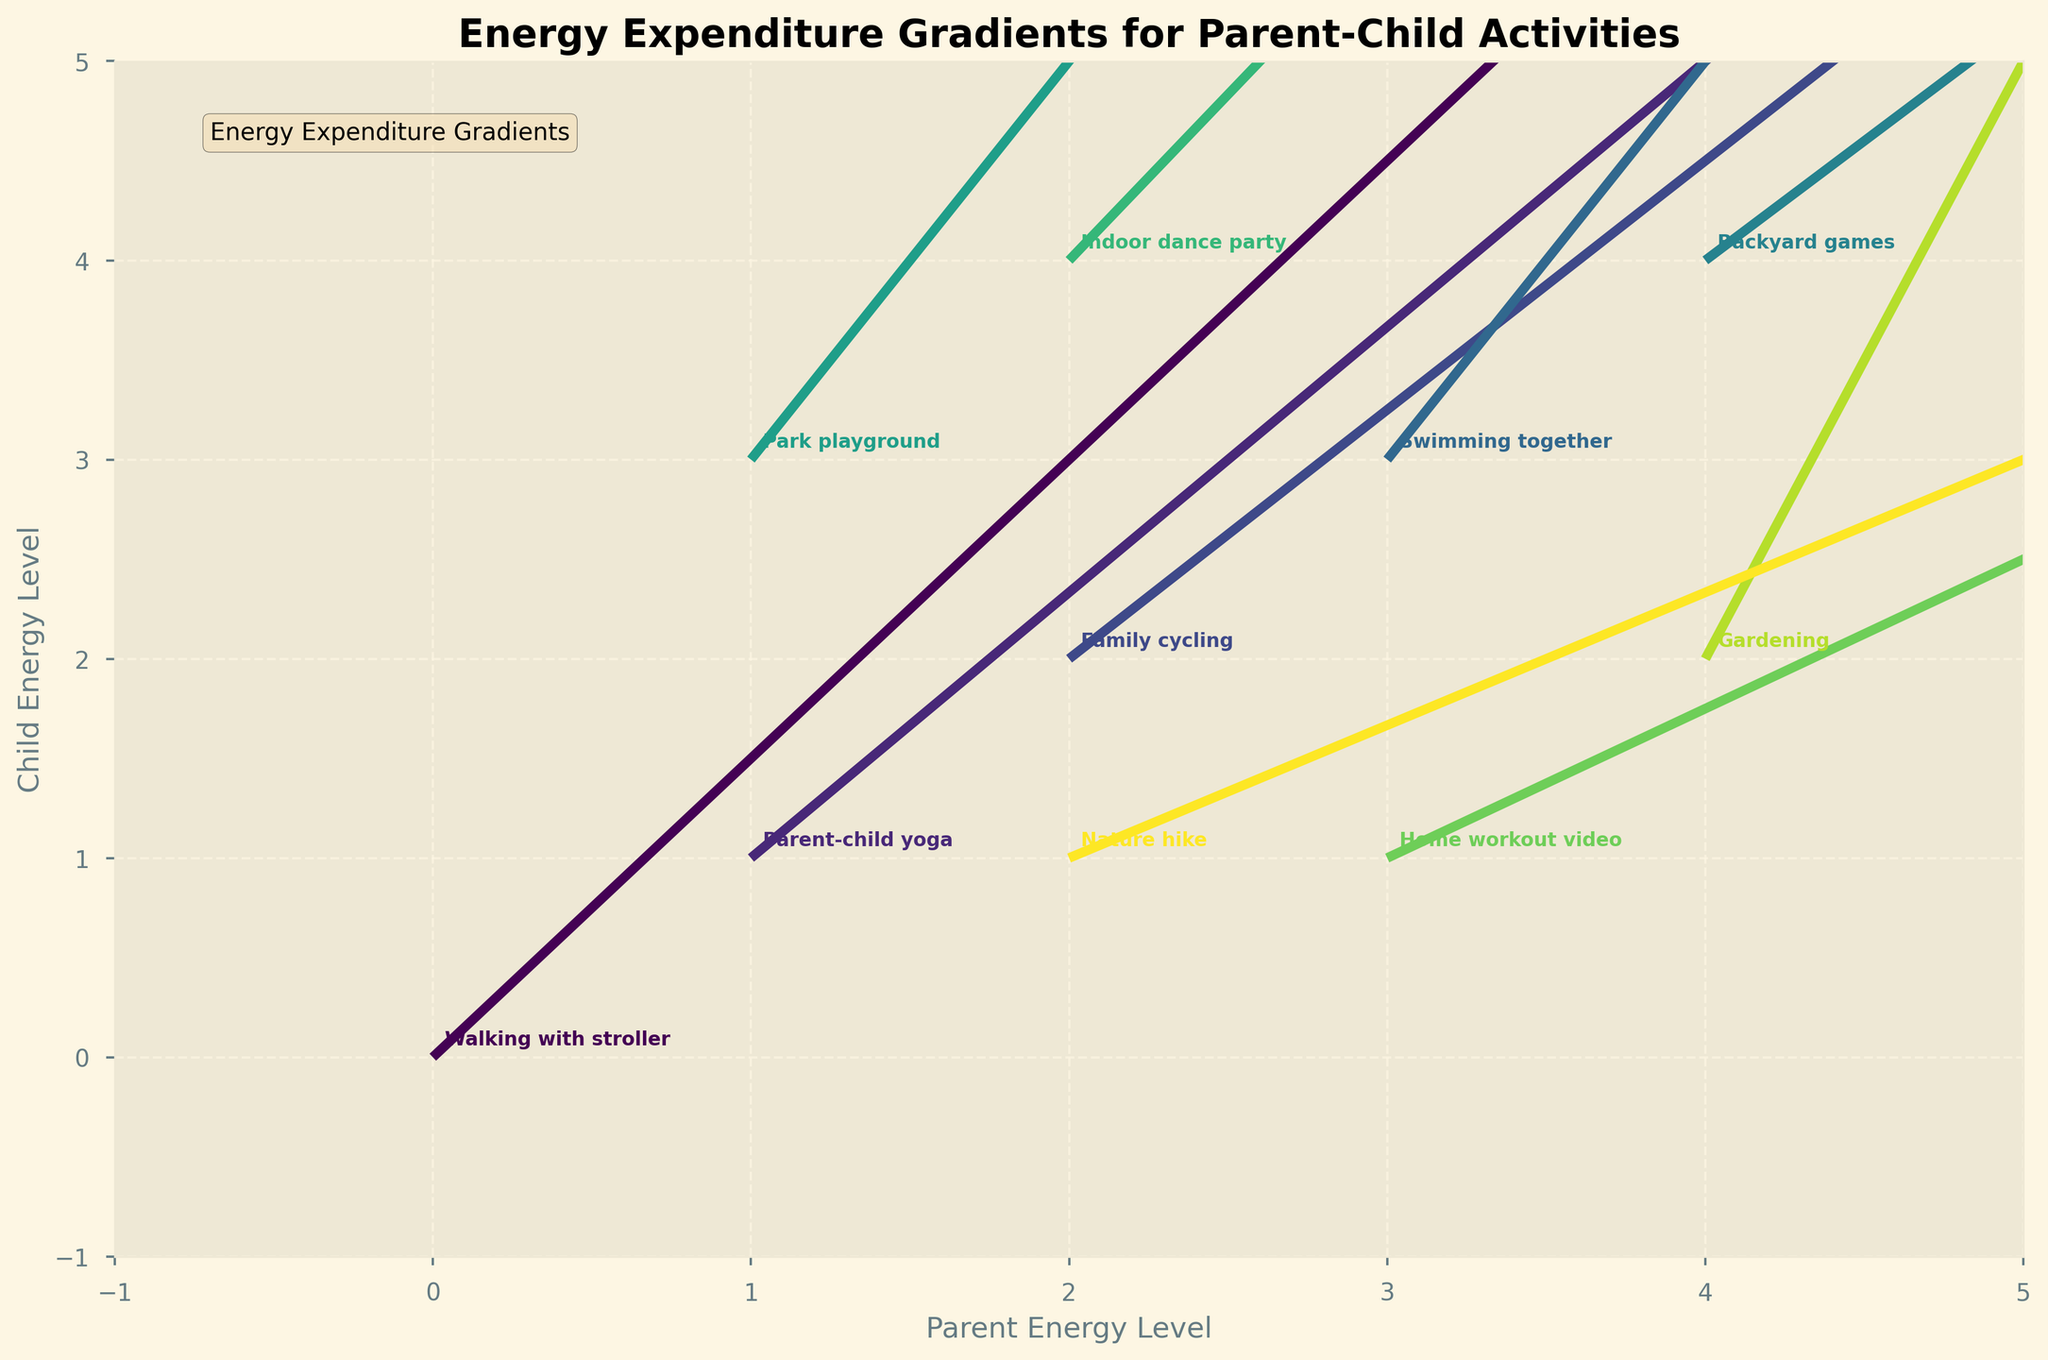How many activities are plotted on the figure? Count the total number of activities annotated on the figure. Each activity is represented by a quiver (arrow) with an associated label. By counting the labels, we find there are 10 activities plotted.
Answer: 10 What is the title of the figure? The title of the figure is written at the top of the plot. It summarizes the main topic of the data visualization. The title in the given plot is "Energy Expenditure Gradients for Parent-Child Activities".
Answer: Energy Expenditure Gradients for Parent-Child Activities Which activity has the highest starting energy level for parents? Examine the x-coordinates of each data point to find the activity with the highest value. Among the listed activities, "Backyard games" is located at (4,4), having the highest starting energy level for parents (x=4).
Answer: Backyard games In which activity do parents experience the greatest increase in energy expenditure? Compare the u-values representing the change in parent's energy levels for each activity. The maximum u-value is 5, associated with "Backyard games".
Answer: Backyard games Which activity has the smallest change in energy expenditure for children? Look at the v-values representing the change in children's energy levels for each activity. "Swimming together" has a v-value of 2, which is the smallest among the given activities.
Answer: Swimming together For "Parent-child yoga", what are the starting and ending energy levels for both parent and child? The starting energy levels for "Parent-child yoga" are at coordinate (1,1). The ending energy levels can be found by adding the changes (u,v) to these coordinates, resulting in (1+3, 1+4). Therefore, the starting levels are (1,1), and the ending levels are (4,5).
Answer: Starting: (1,1), Ending: (4,5) Which activity shows the largest increase in energy for both parent and child combined? Calculate the combined changes (u+v) for all activities. The largest combined change is in "Backyard games" with u+v = 5+6 = 11.
Answer: Backyard games How does the energy expenditure change for parents during "Nature hike" compare to "Family cycling"? Compare the u-values for both activities. "Nature hike" has u=3 and "Family cycling" has u=4. Therefore, the energy expenditure change for parents is 1 unit less during "Nature hike" compared to "Family cycling".
Answer: 1 unit less Which activity starts at the lowest energy levels for both parent and child? Find the smallest (x,y) coordinates among all activities. "Walking with stroller" starts at (0,0), which is the lowest.
Answer: Walking with stroller 